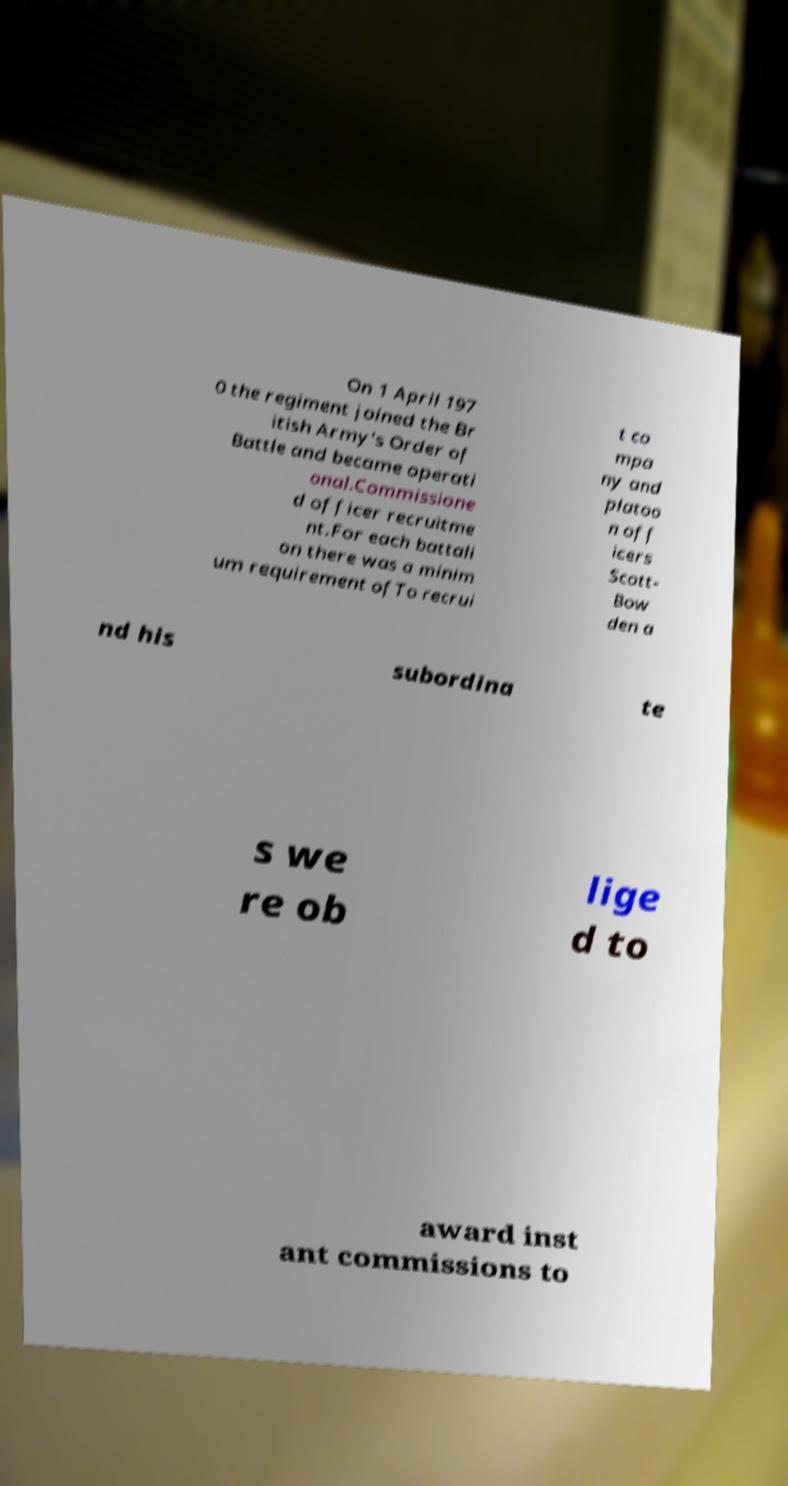Could you assist in decoding the text presented in this image and type it out clearly? On 1 April 197 0 the regiment joined the Br itish Army's Order of Battle and became operati onal.Commissione d officer recruitme nt.For each battali on there was a minim um requirement ofTo recrui t co mpa ny and platoo n off icers Scott- Bow den a nd his subordina te s we re ob lige d to award inst ant commissions to 